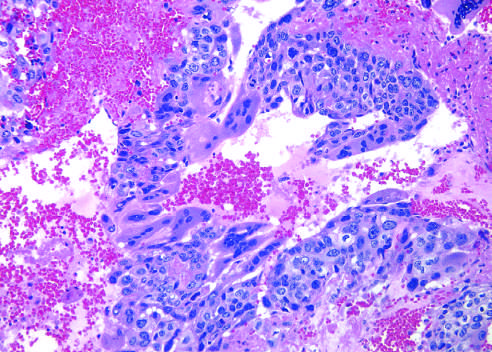what are present?
Answer the question using a single word or phrase. Cytotrophoblastic cells and syncytiotrophoblastic cells 